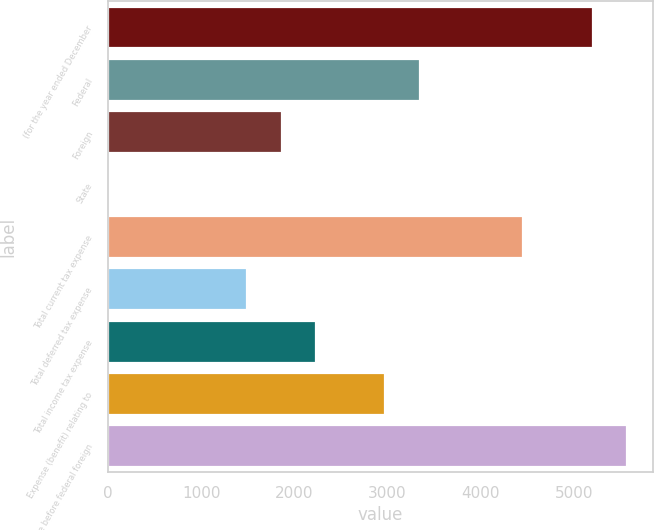<chart> <loc_0><loc_0><loc_500><loc_500><bar_chart><fcel>(for the year ended December<fcel>Federal<fcel>Foreign<fcel>State<fcel>Total current tax expense<fcel>Total deferred tax expense<fcel>Total income tax expense<fcel>Expense (benefit) relating to<fcel>Income before federal foreign<nl><fcel>5198.4<fcel>3345.4<fcel>1863<fcel>10<fcel>4457.2<fcel>1492.4<fcel>2233.6<fcel>2974.8<fcel>5569<nl></chart> 